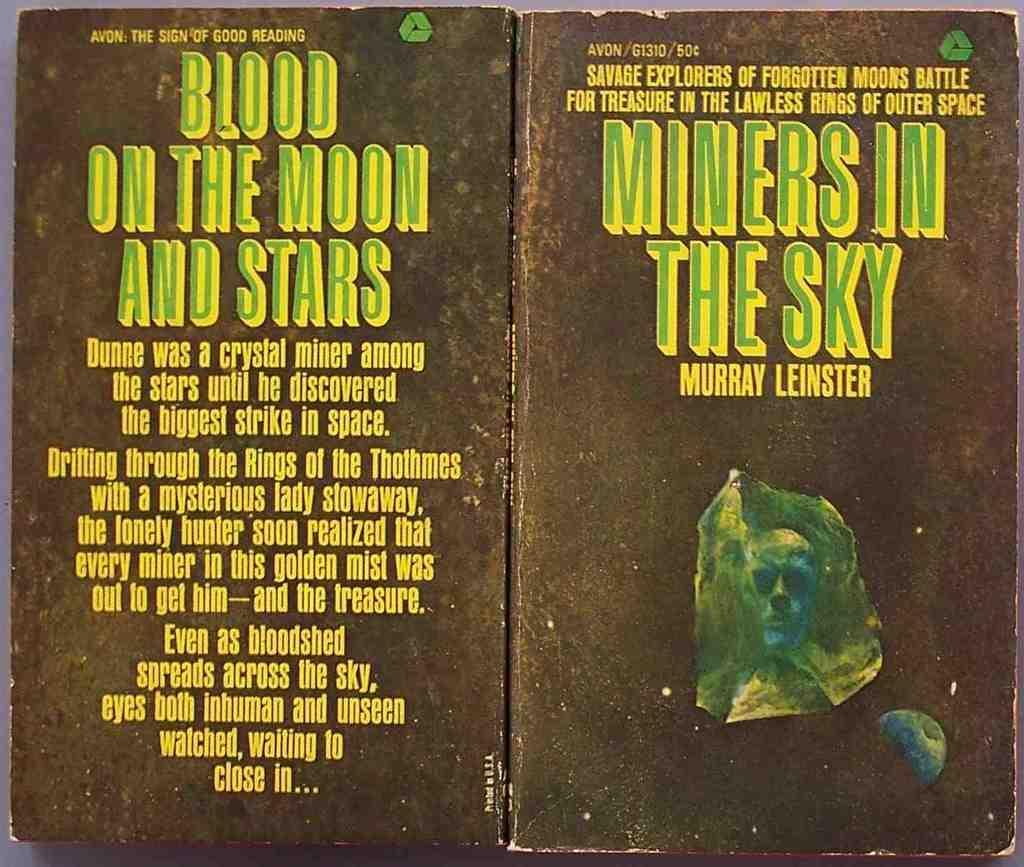<image>
Render a clear and concise summary of the photo. the title miners in the sky that is on the book 